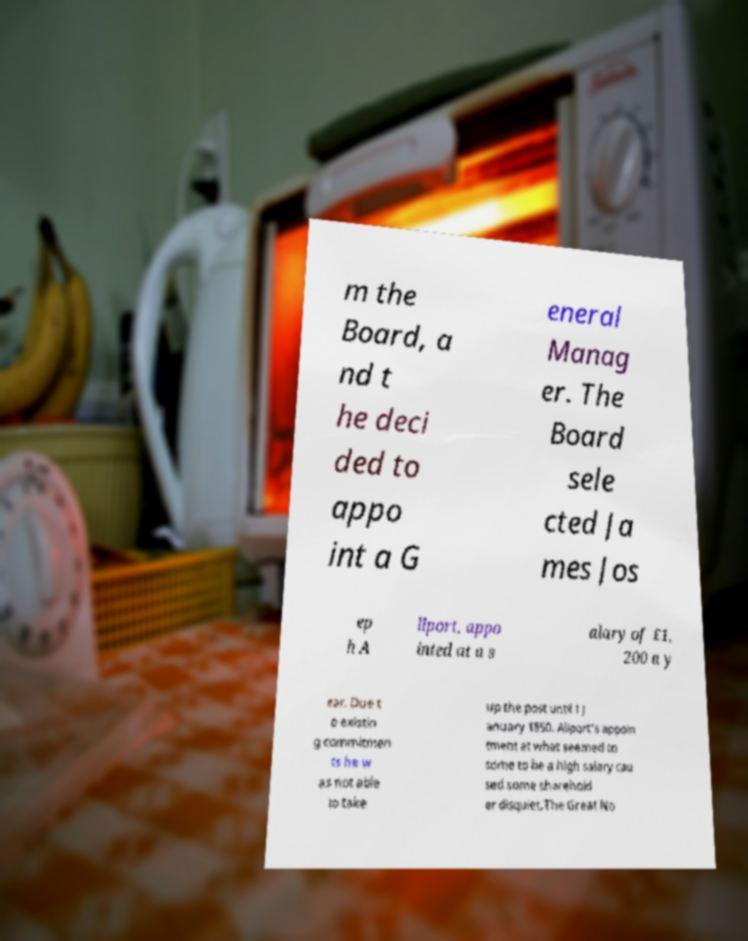I need the written content from this picture converted into text. Can you do that? m the Board, a nd t he deci ded to appo int a G eneral Manag er. The Board sele cted Ja mes Jos ep h A llport, appo inted at a s alary of £1, 200 a y ear. Due t o existin g commitmen ts he w as not able to take up the post until 1 J anuary 1850. Allport's appoin tment at what seemed to some to be a high salary cau sed some sharehold er disquiet.The Great No 